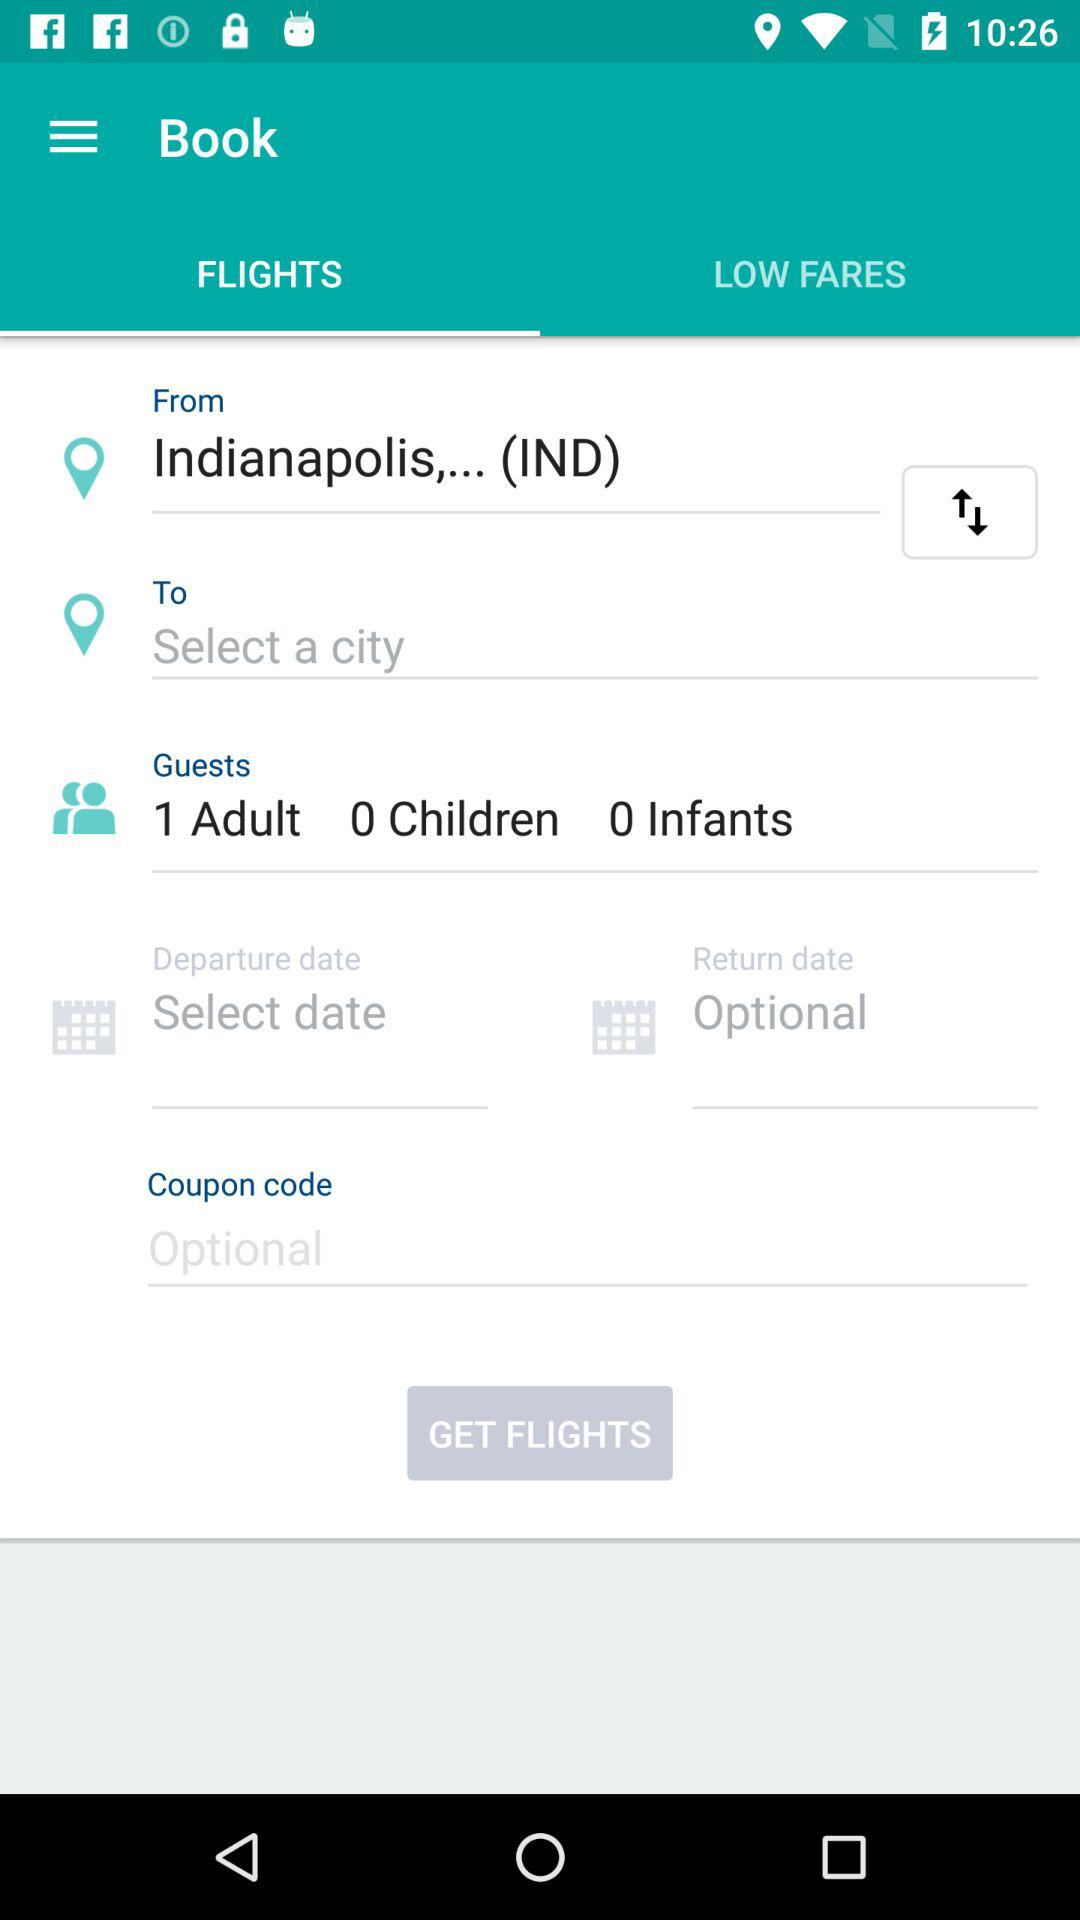How many text inputs are there for the number of guests?
Answer the question using a single word or phrase. 3 